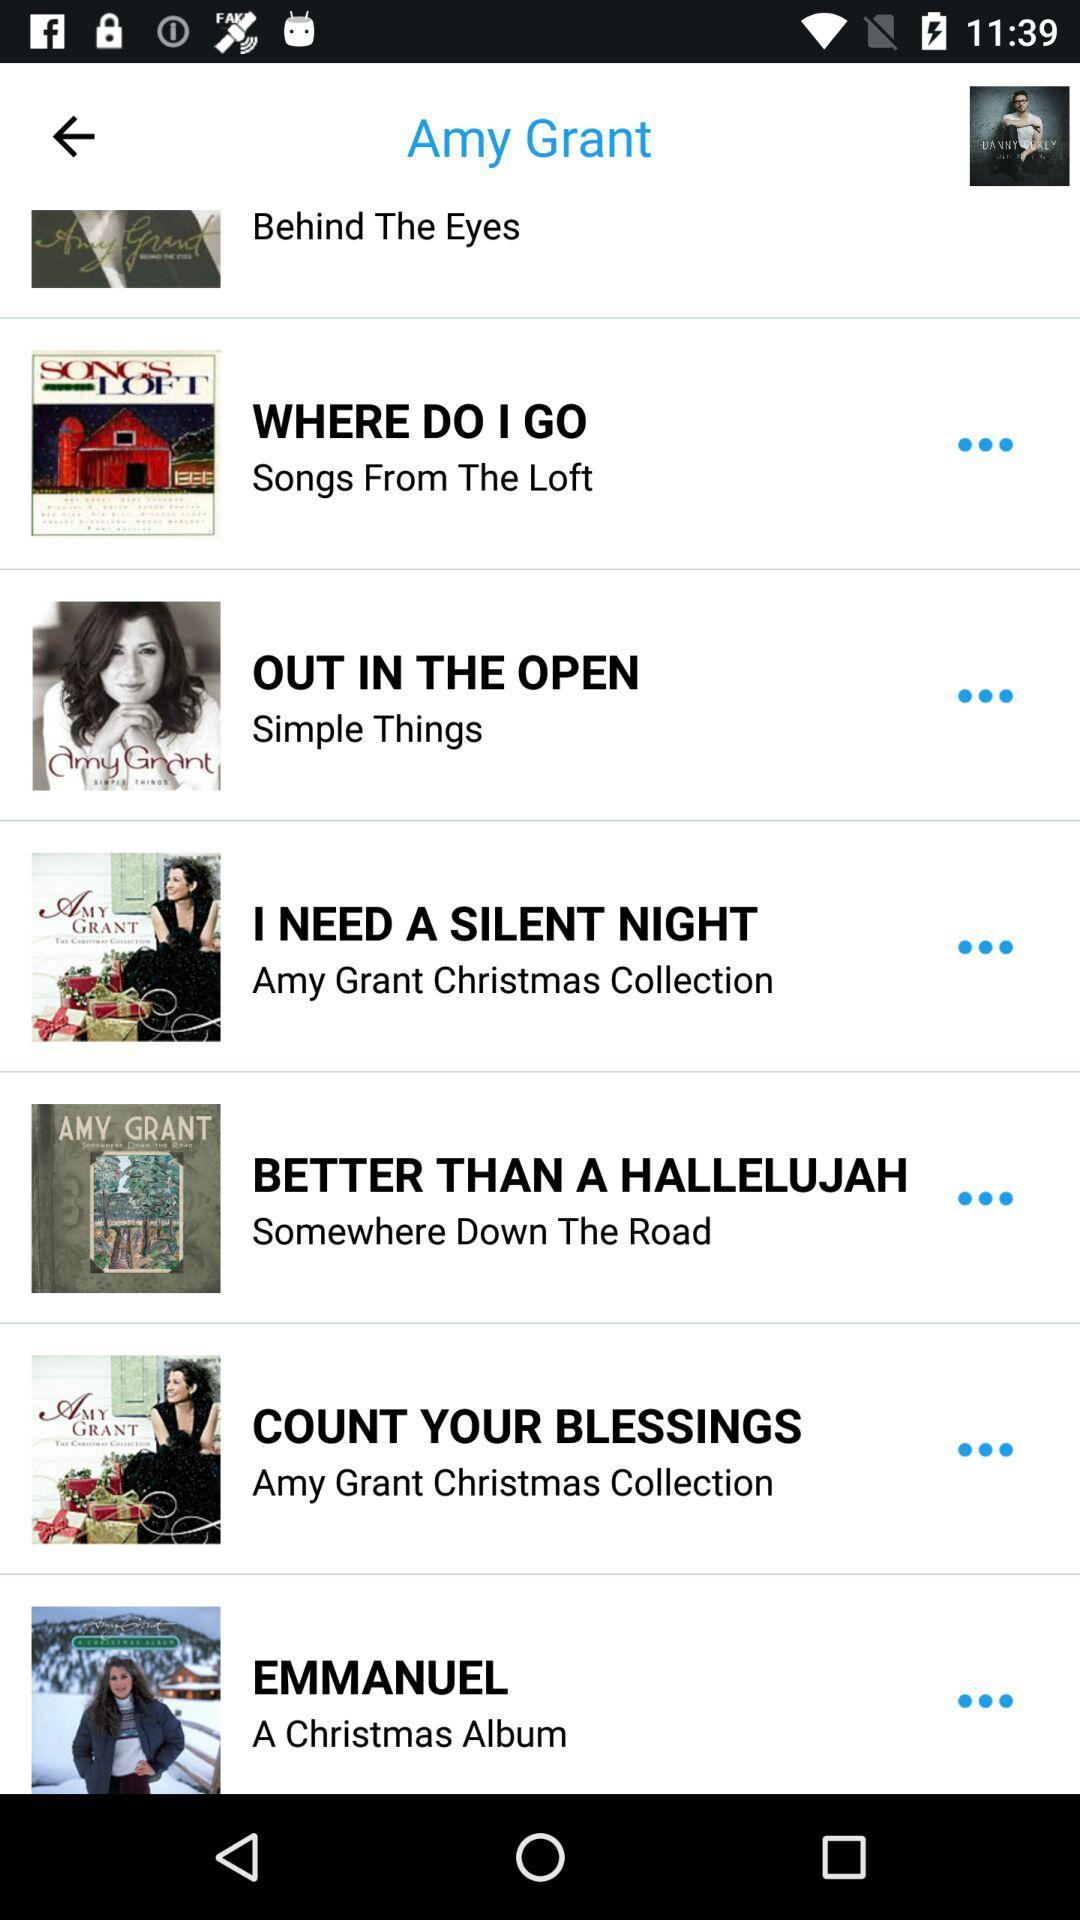Which song is from the "Amy Grant Christmas Collection" album? The song from the "Amy Grant Christmas Collection" album is "COUNT YOUR BLESSINGS". 